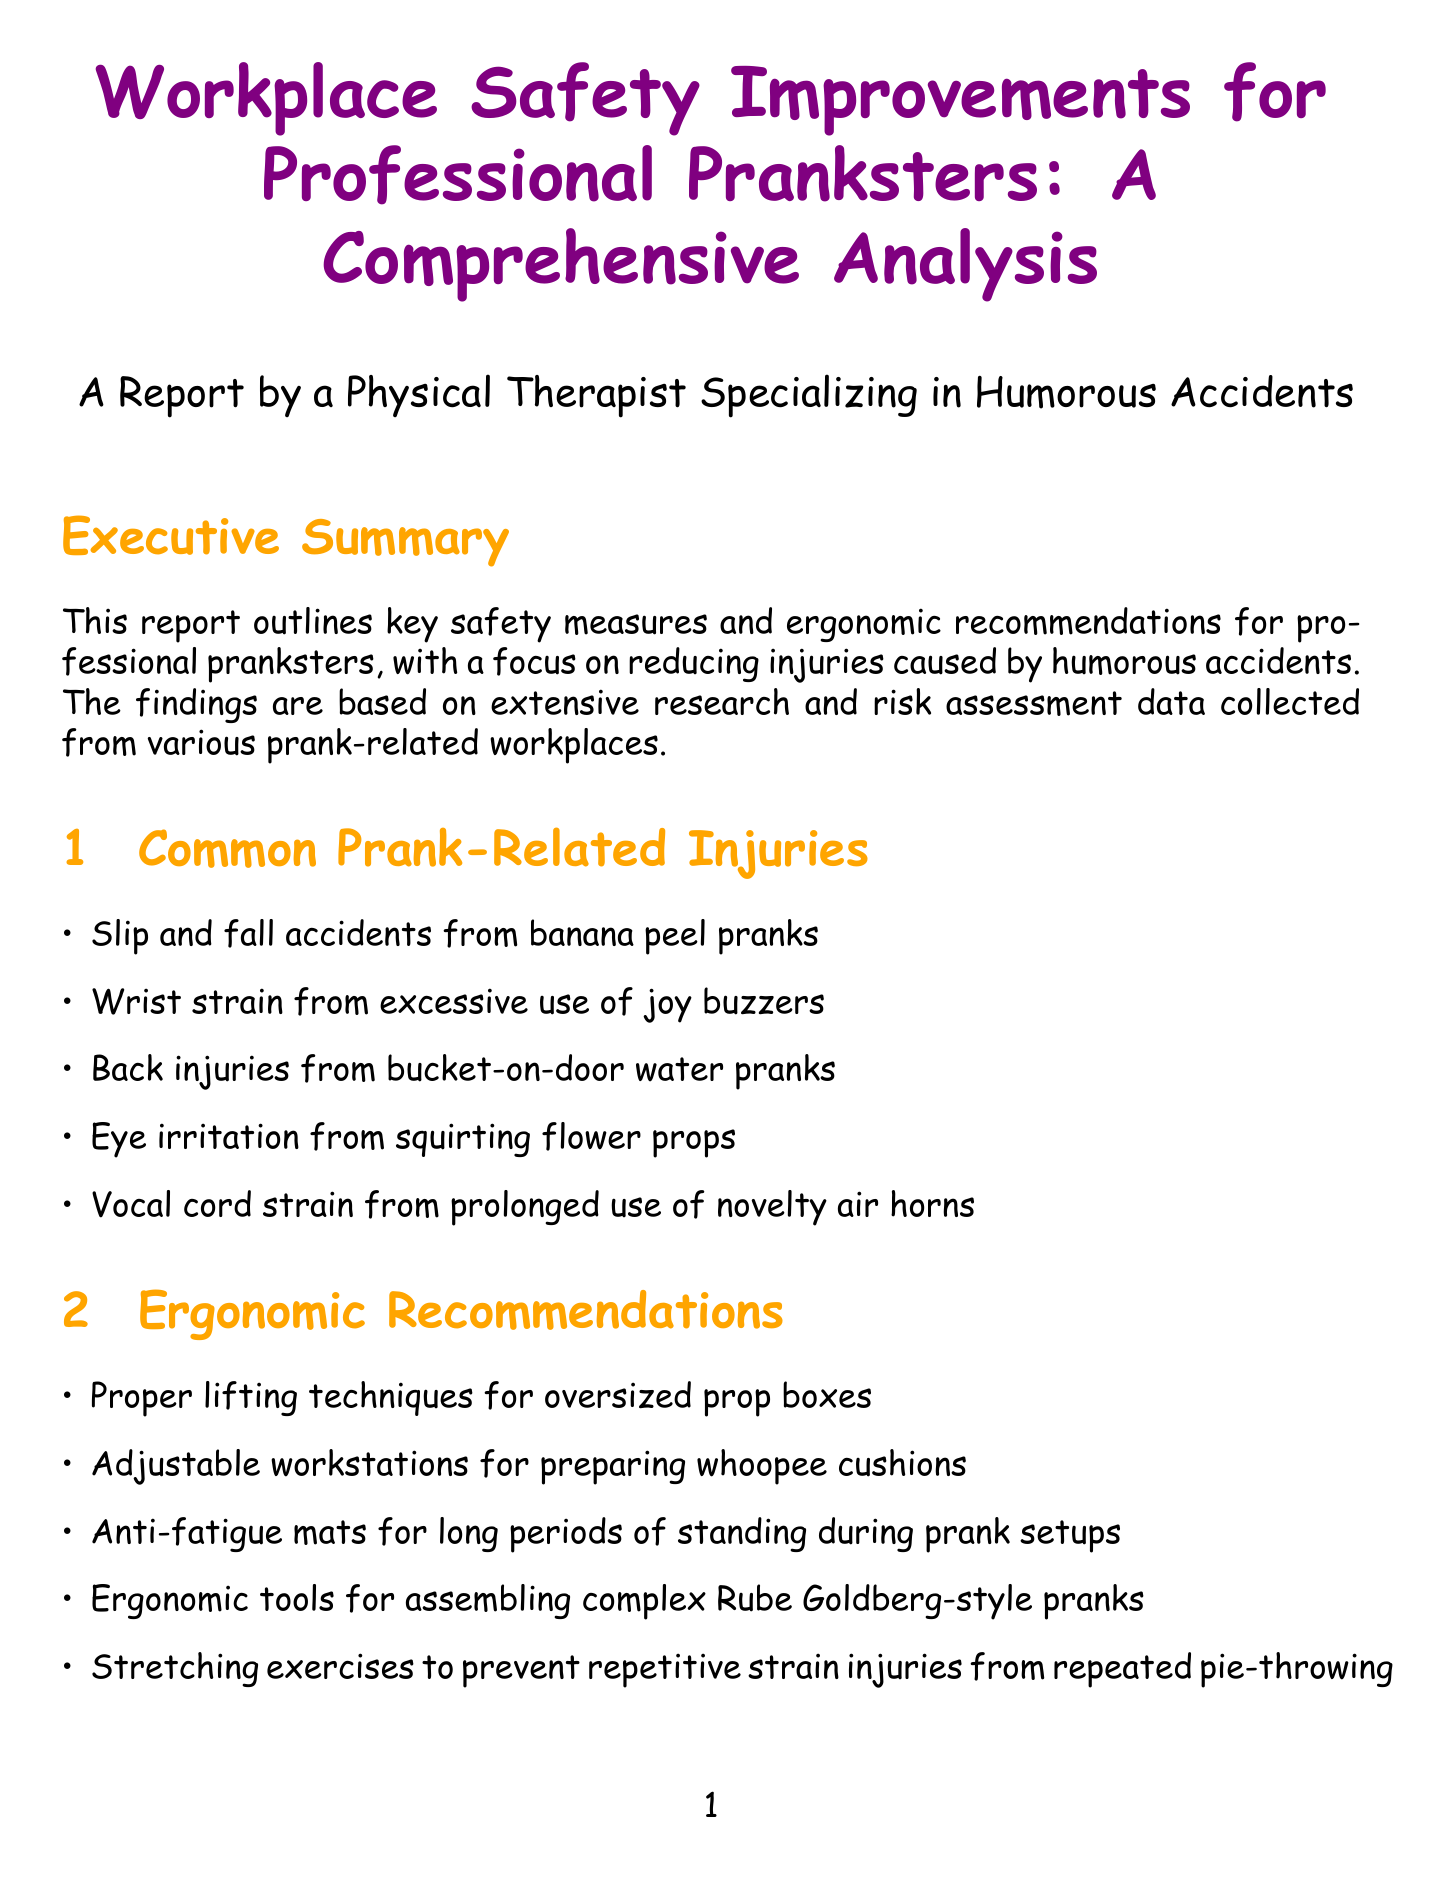what is the title of the report? The title is the main heading of the document, which summarizes its purpose.
Answer: Workplace Safety Improvements for Professional Pranksters: A Comprehensive Analysis what is the most common injury from custard pie throwing? This is found in the risk assessment data section under the specific prank type.
Answer: Shoulder strain what ergonomic recommendation is made for long periods of standing? This can be found in the ergonomic recommendations section, which lists ways to improve safety and comfort.
Answer: Anti-fatigue mats how much was the reduction in wrist and back injuries for Chuckles & Co.? This information is provided in the case study section detailing the outcomes of safety improvements.
Answer: 30% what is the recommended safety gear for confetti cannon operation? This is specified in the risk assessment data for the respective prank type.
Answer: Ear protection, safety goggles how often are safety training sessions recommended? The document emphasizes the importance of regular training sessions to improve safety.
Answer: Regularly what is one future recommendation mentioned in the report? This question asks for a suggestion made for improving prank safety in the future, as stated in the corresponding section.
Answer: Development of AI-powered prank risk prediction software what type of injury is commonly associated with fake spider placement? "Most common injury" for this prank type can be found in the risk assessment data section.
Answer: Ladder falls what should be implemented in each department according to the workplace safety improvements? This reflects a suggestion for organizational structure within prank-oriented workplaces.
Answer: Prank Safety Officer 